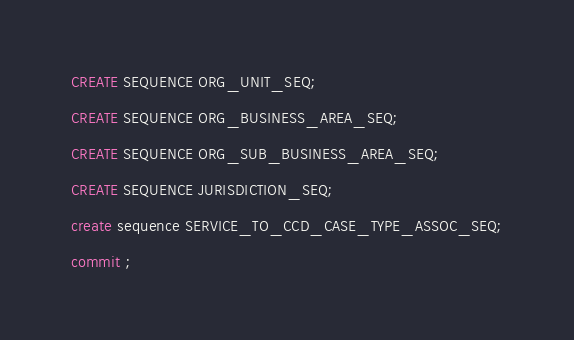<code> <loc_0><loc_0><loc_500><loc_500><_SQL_>CREATE SEQUENCE ORG_UNIT_SEQ;

CREATE SEQUENCE ORG_BUSINESS_AREA_SEQ;

CREATE SEQUENCE ORG_SUB_BUSINESS_AREA_SEQ;

CREATE SEQUENCE JURISDICTION_SEQ;

create sequence SERVICE_TO_CCD_CASE_TYPE_ASSOC_SEQ;

commit ;
</code> 